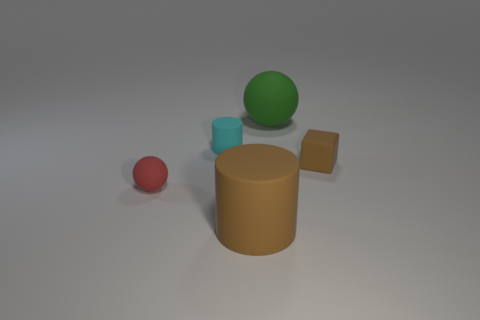Add 2 yellow metal balls. How many objects exist? 7 Subtract all spheres. How many objects are left? 3 Add 1 large rubber cylinders. How many large rubber cylinders are left? 2 Add 1 cyan things. How many cyan things exist? 2 Subtract 0 cyan spheres. How many objects are left? 5 Subtract all tiny green matte blocks. Subtract all big green things. How many objects are left? 4 